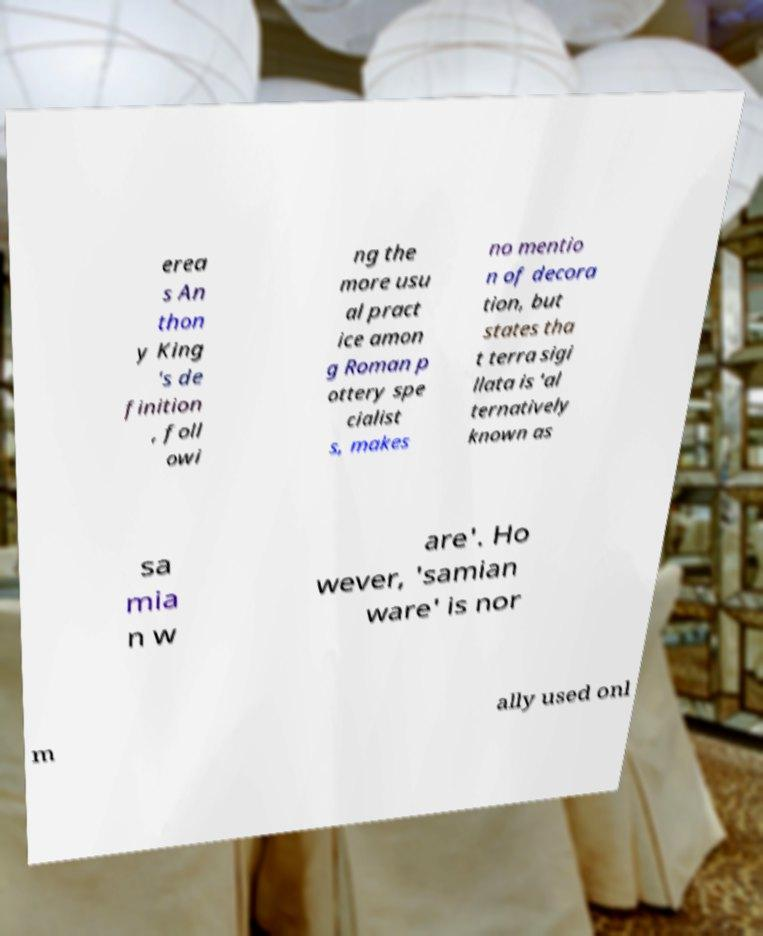There's text embedded in this image that I need extracted. Can you transcribe it verbatim? erea s An thon y King 's de finition , foll owi ng the more usu al pract ice amon g Roman p ottery spe cialist s, makes no mentio n of decora tion, but states tha t terra sigi llata is 'al ternatively known as sa mia n w are'. Ho wever, 'samian ware' is nor m ally used onl 